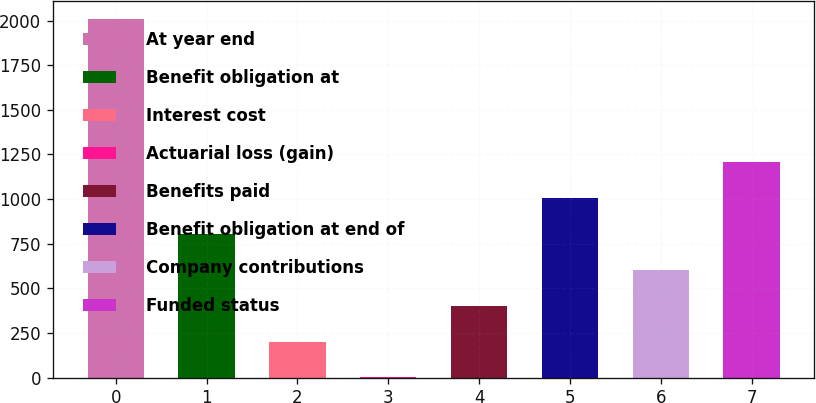Convert chart. <chart><loc_0><loc_0><loc_500><loc_500><bar_chart><fcel>At year end<fcel>Benefit obligation at<fcel>Interest cost<fcel>Actuarial loss (gain)<fcel>Benefits paid<fcel>Benefit obligation at end of<fcel>Company contributions<fcel>Funded status<nl><fcel>2009<fcel>804.2<fcel>201.8<fcel>1<fcel>402.6<fcel>1005<fcel>603.4<fcel>1205.8<nl></chart> 